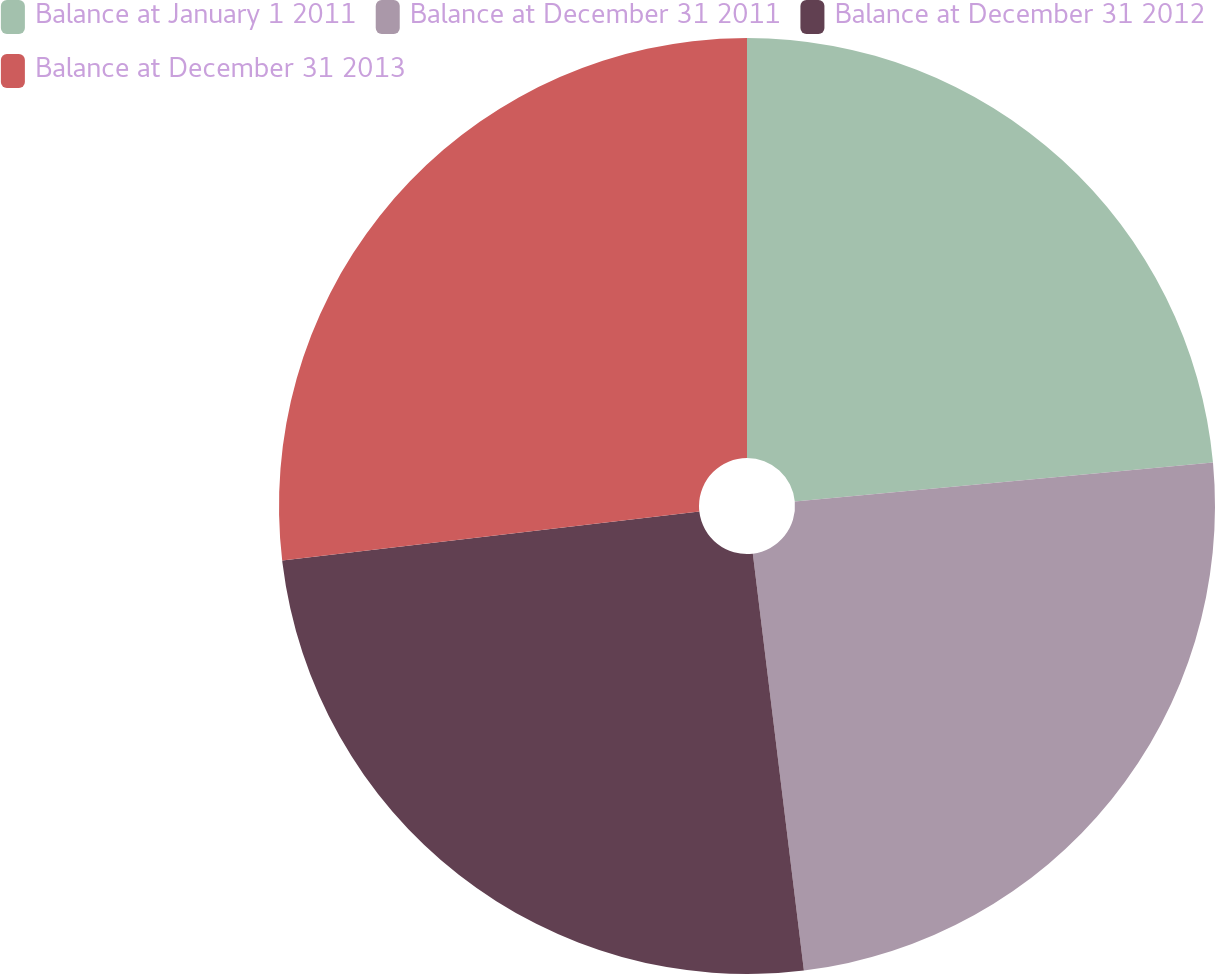<chart> <loc_0><loc_0><loc_500><loc_500><pie_chart><fcel>Balance at January 1 2011<fcel>Balance at December 31 2011<fcel>Balance at December 31 2012<fcel>Balance at December 31 2013<nl><fcel>23.52%<fcel>24.54%<fcel>25.08%<fcel>26.86%<nl></chart> 